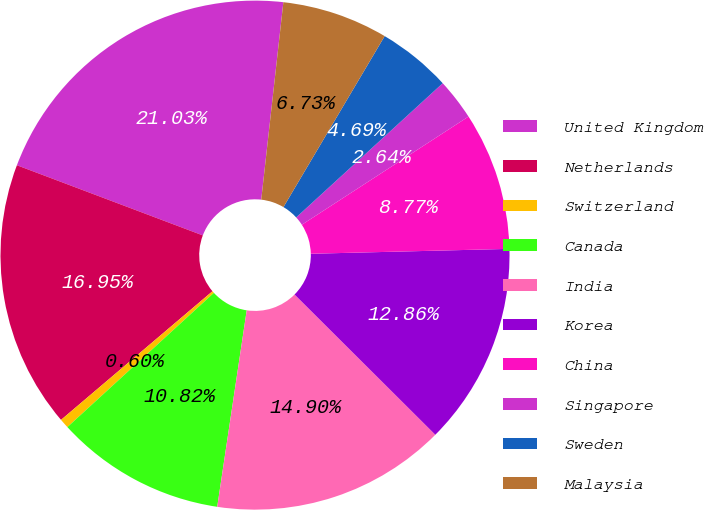<chart> <loc_0><loc_0><loc_500><loc_500><pie_chart><fcel>United Kingdom<fcel>Netherlands<fcel>Switzerland<fcel>Canada<fcel>India<fcel>Korea<fcel>China<fcel>Singapore<fcel>Sweden<fcel>Malaysia<nl><fcel>21.03%<fcel>16.95%<fcel>0.6%<fcel>10.82%<fcel>14.9%<fcel>12.86%<fcel>8.77%<fcel>2.64%<fcel>4.69%<fcel>6.73%<nl></chart> 